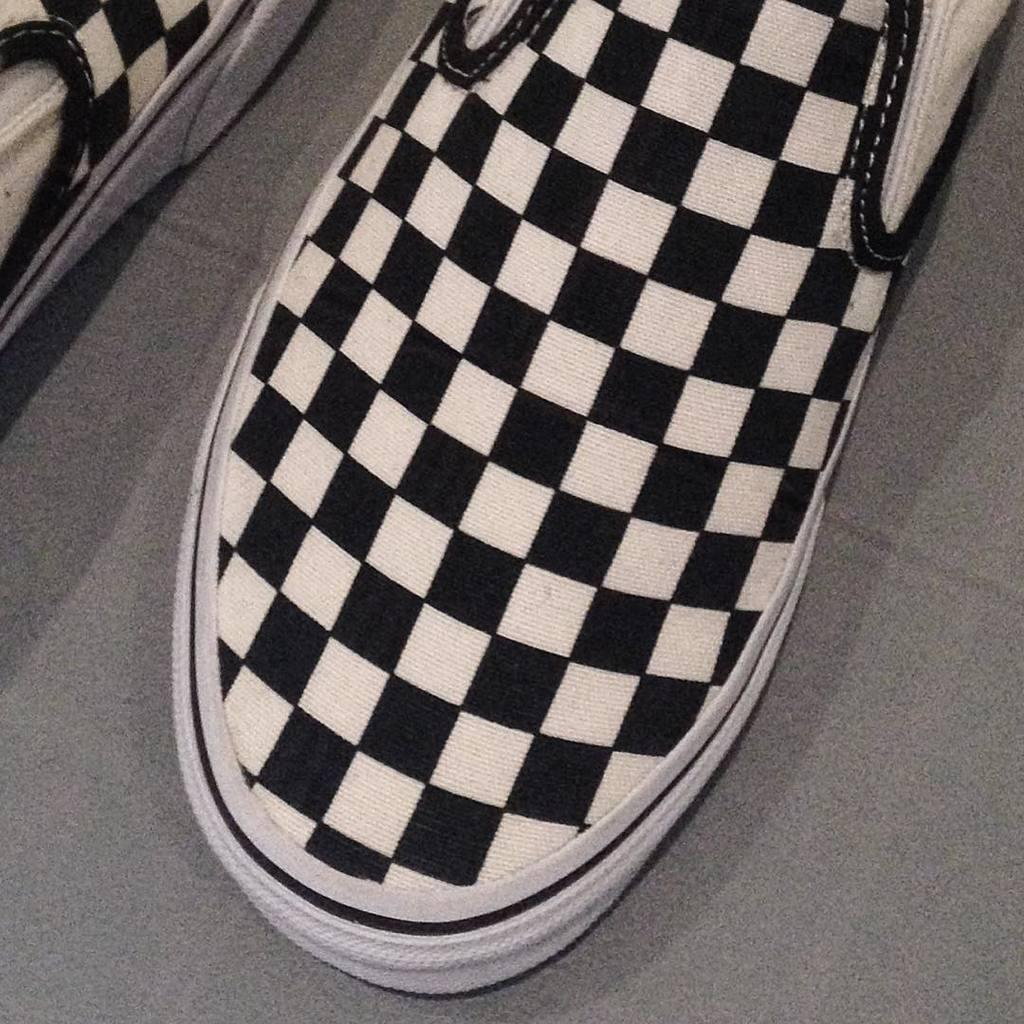What type of footwear is visible in the image? There are shoes in the image. What is located on the floor in the image? There is a floor mat in the image. What color is the floor mat? The floor mat is gray in color. What type of rake is being used on the floor mat in the image? There is no rake visible in the image. 